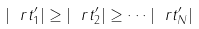Convert formula to latex. <formula><loc_0><loc_0><loc_500><loc_500>| \ r t _ { 1 } ^ { \prime } | \geq | \ r t _ { 2 } ^ { \prime } | \geq \cdots | \ r t _ { N } ^ { \prime } |</formula> 